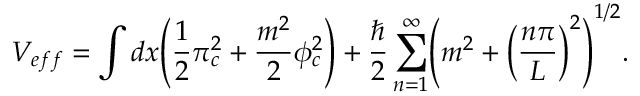<formula> <loc_0><loc_0><loc_500><loc_500>V _ { e f f } = \int d x \left ( \frac { 1 } { 2 } \pi _ { c } ^ { 2 } + \frac { m ^ { 2 } } { 2 } \phi _ { c } ^ { 2 } \right ) + \frac { } { 2 } \sum _ { n = 1 } ^ { \infty } \left ( m ^ { 2 } + \left ( \frac { n \pi } { L } \right ) ^ { 2 } \right ) ^ { 1 / 2 } .</formula> 